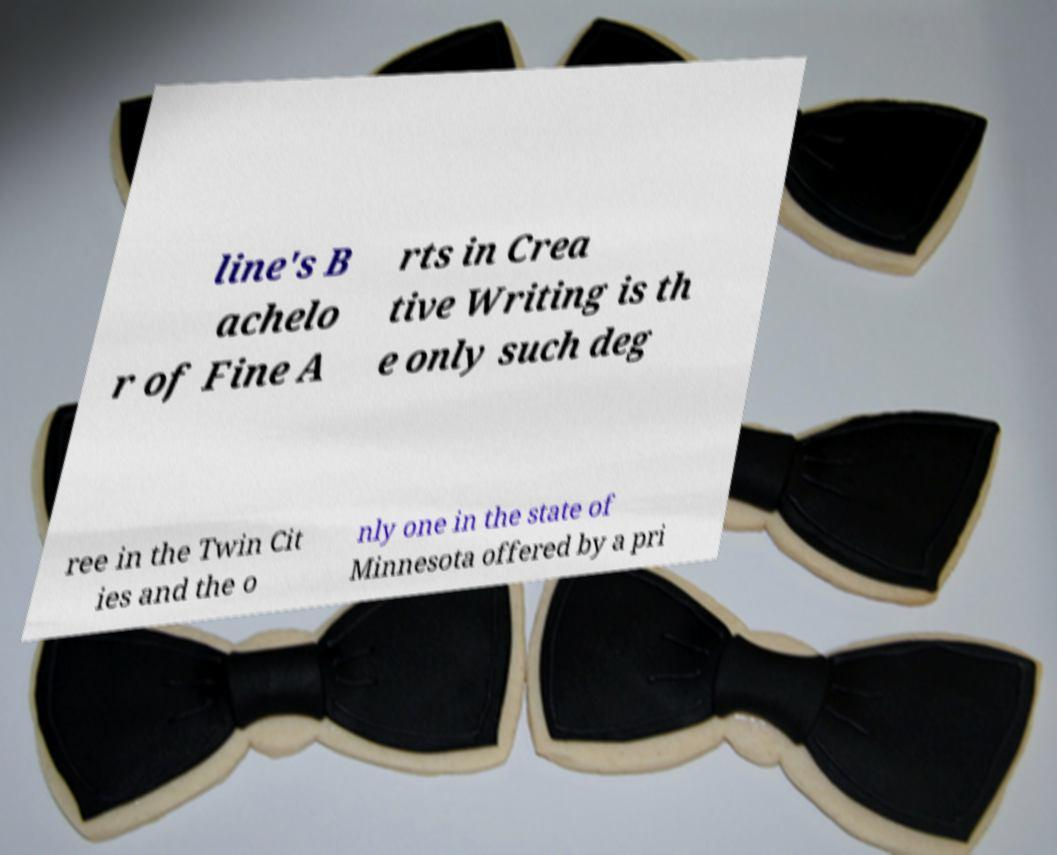What messages or text are displayed in this image? I need them in a readable, typed format. line's B achelo r of Fine A rts in Crea tive Writing is th e only such deg ree in the Twin Cit ies and the o nly one in the state of Minnesota offered by a pri 